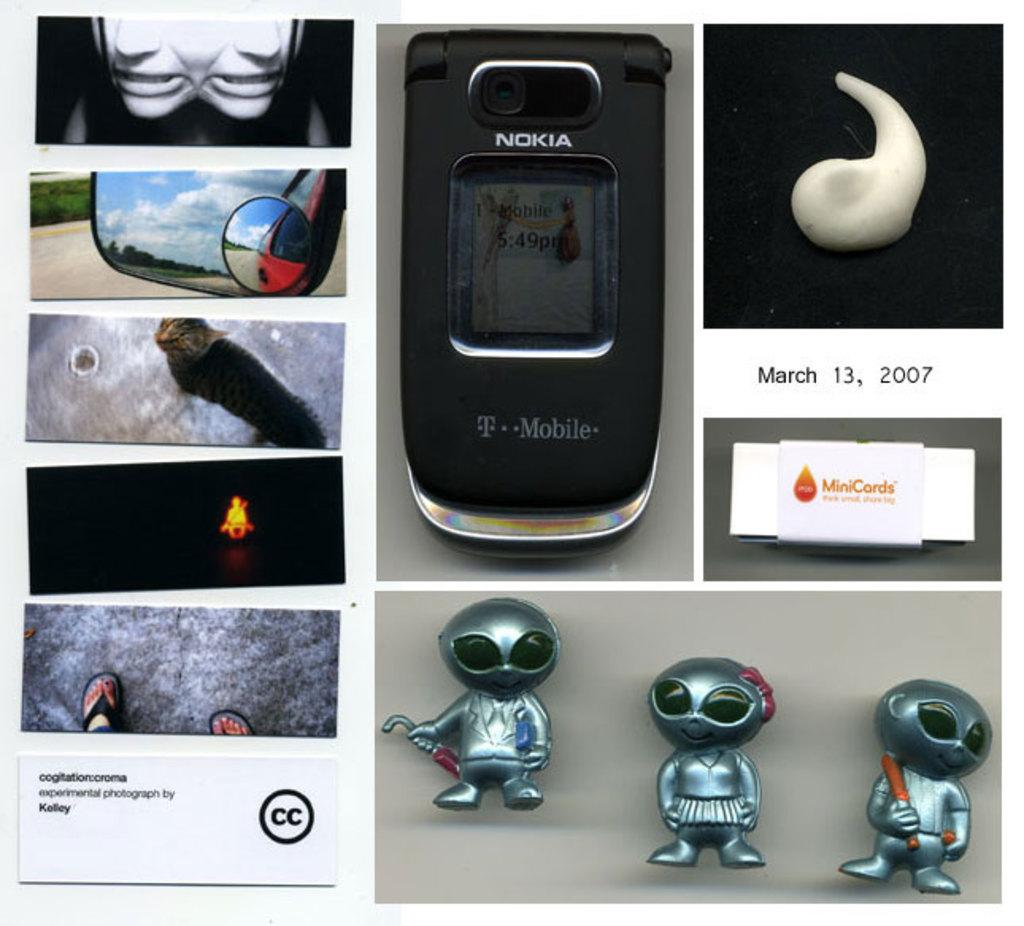<image>
Offer a succinct explanation of the picture presented. a collage of different images including a Nokia T Mobile phone 